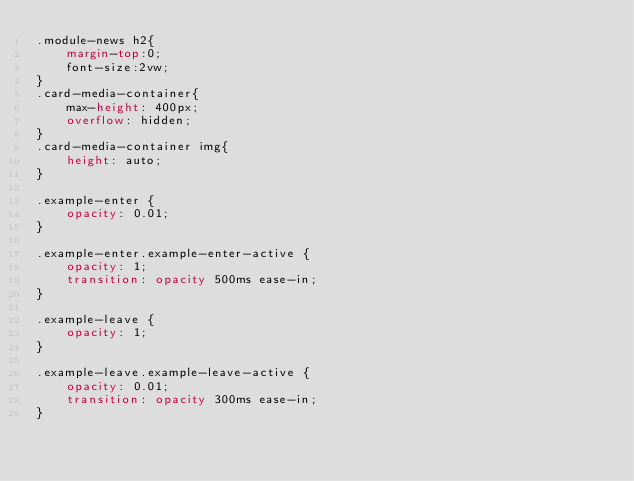Convert code to text. <code><loc_0><loc_0><loc_500><loc_500><_CSS_>.module-news h2{
    margin-top:0;
    font-size:2vw;
}
.card-media-container{
    max-height: 400px;
    overflow: hidden;
}
.card-media-container img{
    height: auto;
}

.example-enter {
    opacity: 0.01;
}

.example-enter.example-enter-active {
    opacity: 1;
    transition: opacity 500ms ease-in;
}

.example-leave {
    opacity: 1;
}

.example-leave.example-leave-active {
    opacity: 0.01;
    transition: opacity 300ms ease-in;
}</code> 